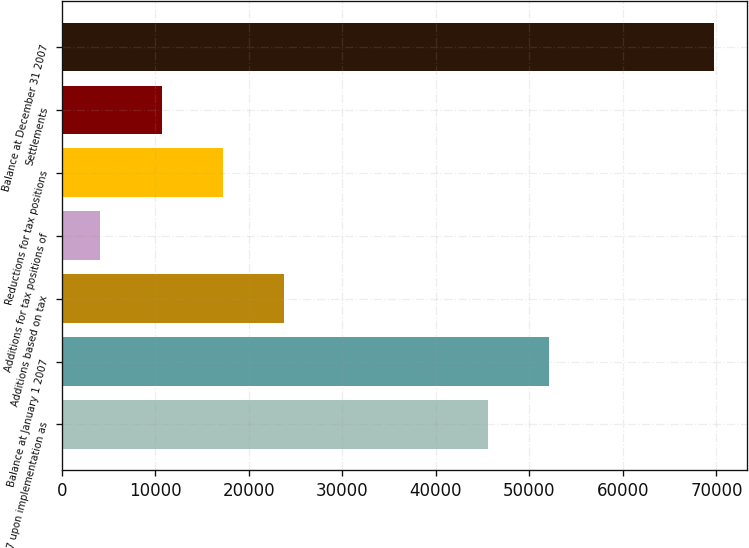Convert chart to OTSL. <chart><loc_0><loc_0><loc_500><loc_500><bar_chart><fcel>2007 upon implementation as<fcel>Balance at January 1 2007<fcel>Additions based on tax<fcel>Additions for tax positions of<fcel>Reductions for tax positions<fcel>Settlements<fcel>Balance at December 31 2007<nl><fcel>45570<fcel>52130.1<fcel>23813.3<fcel>4133<fcel>17253.2<fcel>10693.1<fcel>69734<nl></chart> 